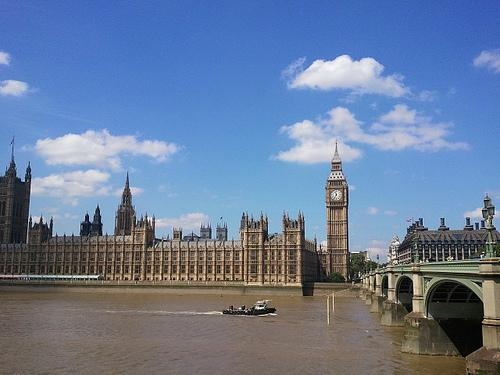What are the noticeable features of the bridge, and what is its color? The bridge has arches, and it is green in color. Identify and count the types of objects present in the image. There are 5 types of objects: a clock tower (1), buildings (several), a boat (1), a bridge (1), and flags (multiple). What are the prominent colors in the image, and where can they be found? Brown (water, buildings), blue (sky), green (bridge), white (clock face, clouds), and red (flags). What type of boat can be seen in the image, and what is it doing? A small, dark-colored boat is moving through the brown river water, leaving a wake behind it. What do the flags on top of the buildings represent? The flags likely represent the United Kingdom, signifying government buildings or a display of national pride. Explain the position of the clock tower in relation to the river and other objects. The clock tower is right next to the river and is surrounded by other buildings, including the House of Parliament. List the elements in the image that indicate its location. Big Ben, the House of Parliament, the River Thames, and the British flag imply that this image is set in London. What time does the clock on the clock tower show? The clock shows 25 minutes until 11, or 10:35. Describe the architectural style of the buildings in the image. The buildings have a Gothic architecture style with pointed arches, ornate detailing, and numerous windows. Describe the weather conditions visible in the image. The weather appears to be clear with blue skies, a few sparse white clouds, and no signs of precipitation. Is the clock tower a bright shade of pink? There is no mention of the clock tower being pink in the information provided, thus making this instruction misleading. Describe the position of Big Ben relative to the river. Big Ben is next to the river. Identify the main object positioned at coordinates X:293, Y:130 along with its width and height. A huge clock tower with a width of 85 and a height of 85. Which building has a flag on it and what are the coordinates, width, and height of that object? The House of Parliament has a flag, located at X:4, Y:133 with a width of 17 and a height of 17. What is the main sentiment expressed by the image? The sentiment is neutral, as it is mainly a cityscape. What is the time shown on the clock tower? The clock reads 25 minutes to 11. From the image, which building is flying a flag on top of it? Provide the coordinates, width, and height of the flag. The building with a flag at the top is at X:6, Y:128 with a width of 20 and a height of 20. What is the architectural style of the buildings in the cityscape? The architectural style is mainly gothic. What is the quality of the image like? Are the details clear and well-defined? The image quality is good, with clear details and well-defined objects. Is the sky filled with dark storm clouds? The information provided only talks about sparse white clouds and clear blue skies. This instruction contradicts the given information by suggesting storm clouds. Is there any anomaly present in the image such as out-of-place objects, strange colors, or irregular shapes? No visible anomalies are present in the image. Does the boat on the river have large, red sails? None of the information about the boat indicates that it has sails, let alone red ones. This instruction adds false details to the boat. Can you see any flying airplanes in the background of the image? None of the details mention airplanes in the background, so adding this instruction would mislead viewers into searching for nonexistent objects. What type of weather is depicted in the image? Describe it. Clear blue skies with few clouds, indicating good weather. What type of boat is on the river? A small dark-colored boat is on the river. Are there any purple elephants in front of the buildings on the left? The image details don't mention any purple elephants or animals, and adding this as a question creates a misleading instruction. Are there any clouds in the sky? If so, describe their appearance. Yes, there are sparse white puffy clouds in the sky. Is there any text visible in the image? If yes, provide an example. No text is visible in the image. Is there a small child waving a flag on the bridge? The details given do not mention any people on the bridge, and this instruction introduces a new, false element that isn't supported by the image's information. What color is the bridge in the image? The bridge is green. List the objects that are present in the image with their respective dimensions. Clock tower, boats on the river, bridge, flags on buildings, gothic buildings, blue sky with white clouds, and brown river water. Describe the interaction between the boat and the bridge in the image. The boat is going to go under the bridge, passing through its arches. What is the boat doing on the river? The boat is leaving a trail in the river as it moves. What is the main function of the brown building in the image? The brown building is used for governmental functions. Describe the color and attribute of the water in the river. The water is brown and muddy. 